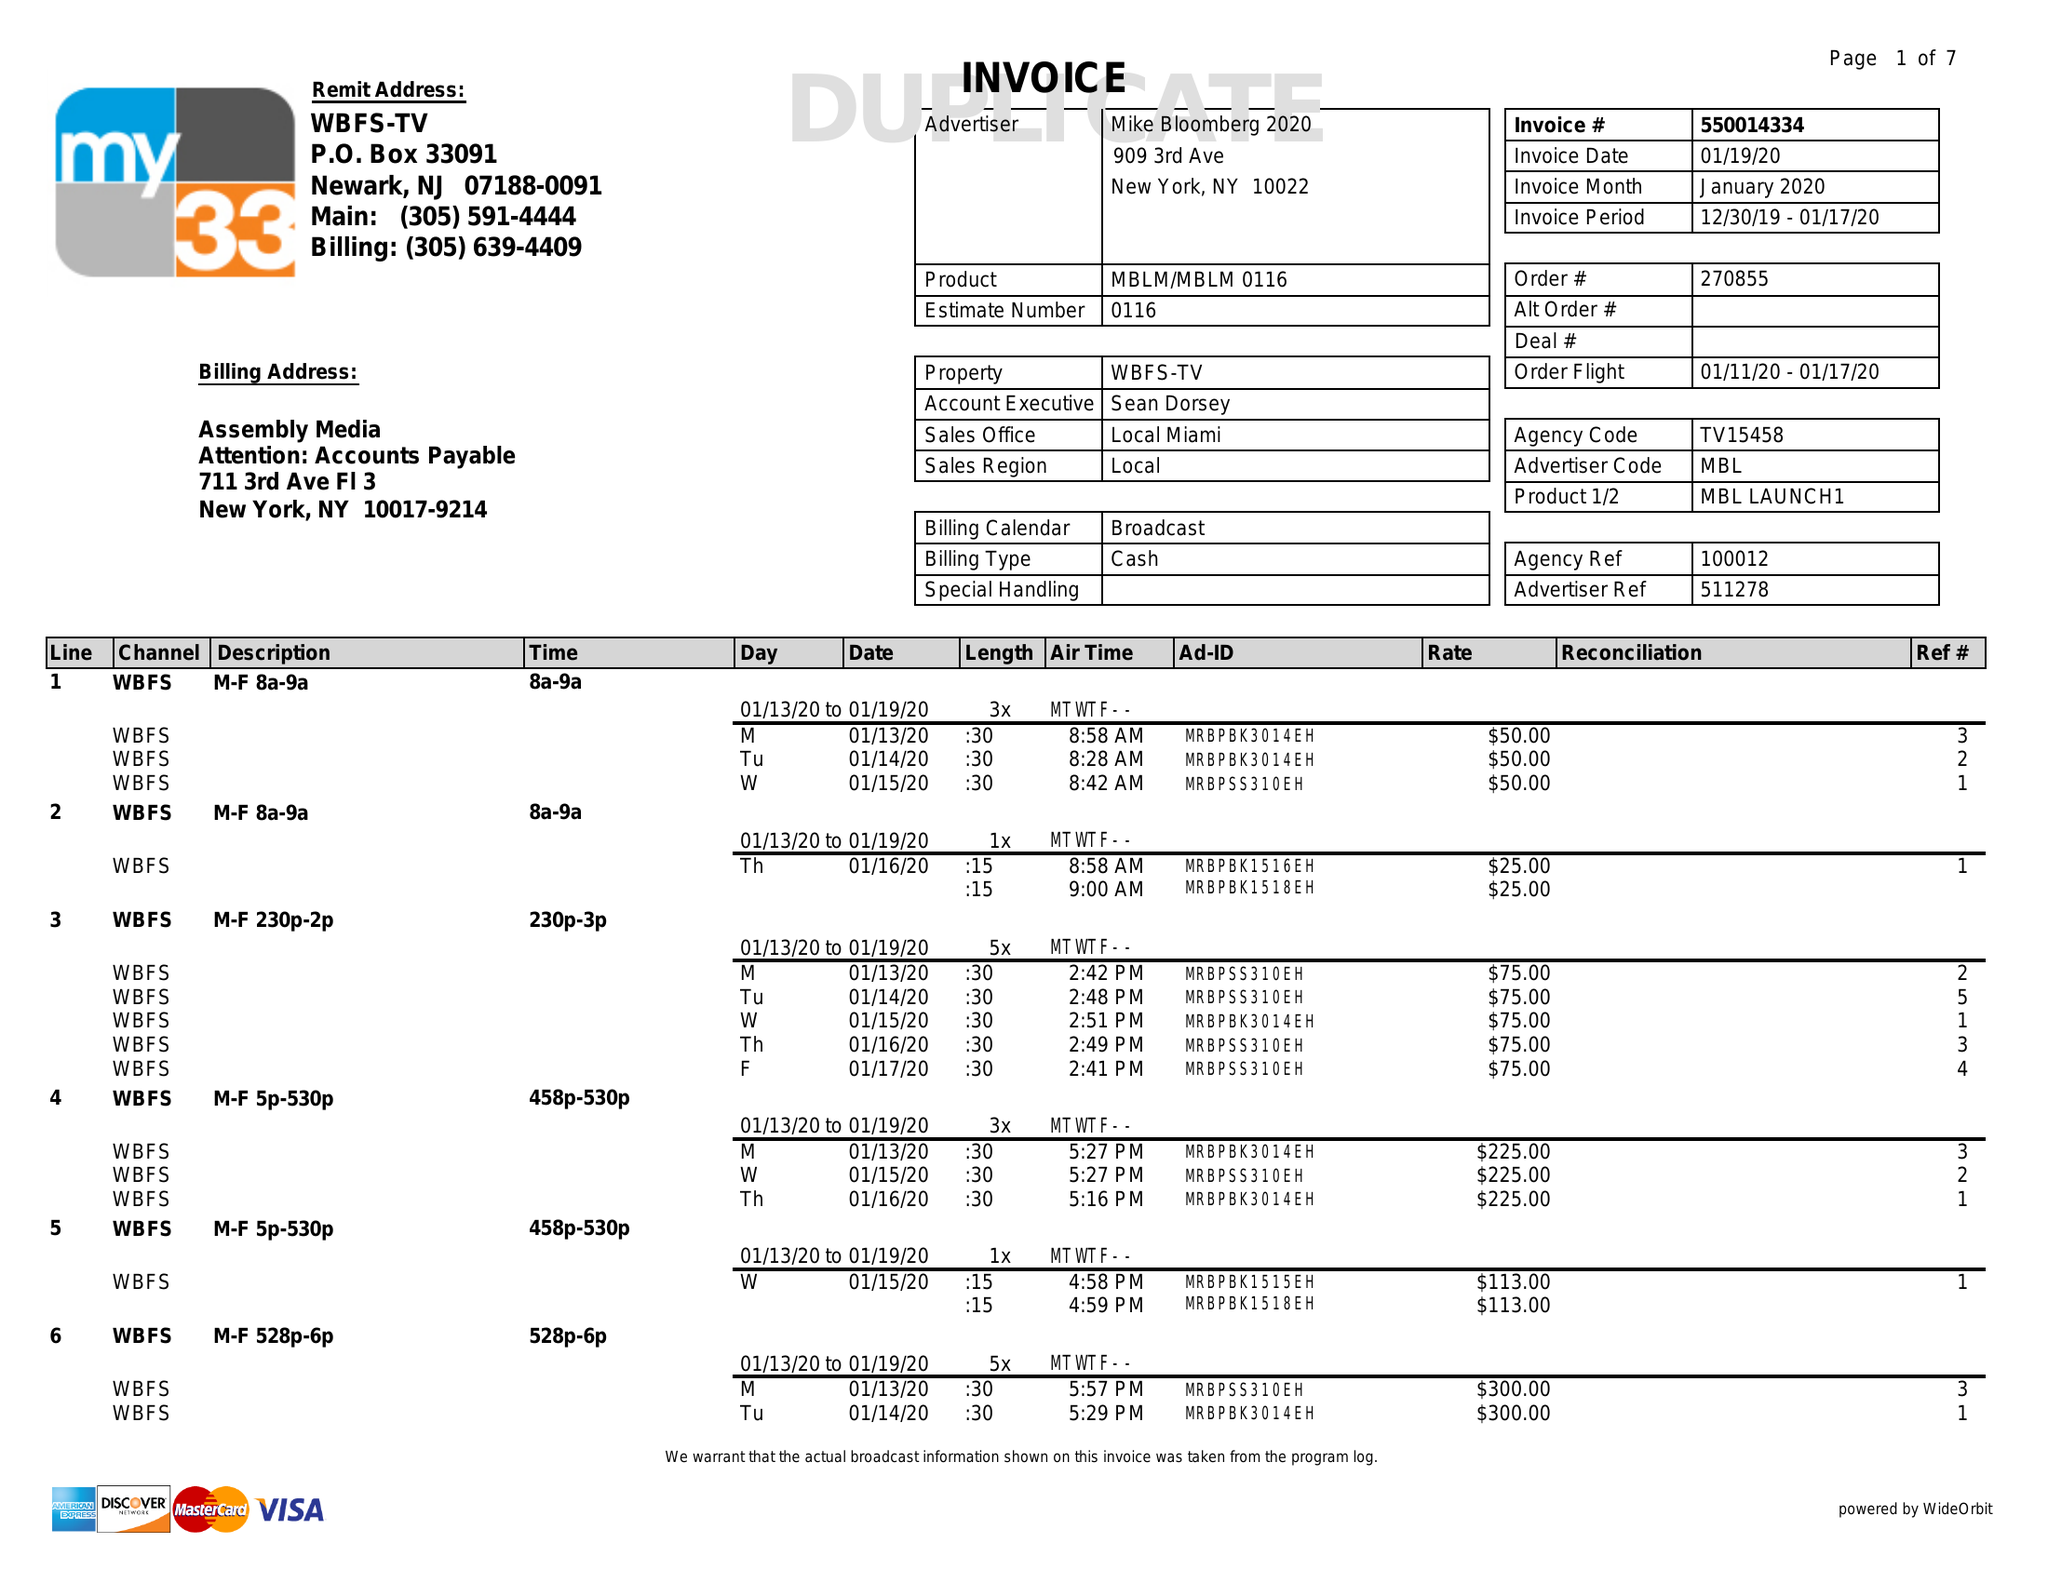What is the value for the contract_num?
Answer the question using a single word or phrase. 550014334 